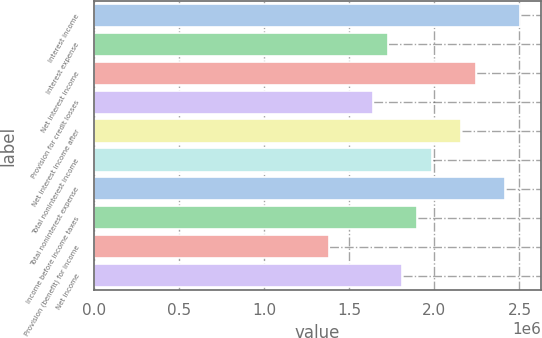Convert chart. <chart><loc_0><loc_0><loc_500><loc_500><bar_chart><fcel>Interest income<fcel>Interest expense<fcel>Net interest income<fcel>Provision for credit losses<fcel>Net interest income after<fcel>Total noninterest income<fcel>Total noninterest expense<fcel>Income before income taxes<fcel>Provision (benefit) for income<fcel>Net income<nl><fcel>2.50363e+06<fcel>1.72664e+06<fcel>2.24463e+06<fcel>1.64031e+06<fcel>2.1583e+06<fcel>1.98563e+06<fcel>2.41729e+06<fcel>1.8993e+06<fcel>1.38131e+06<fcel>1.81297e+06<nl></chart> 